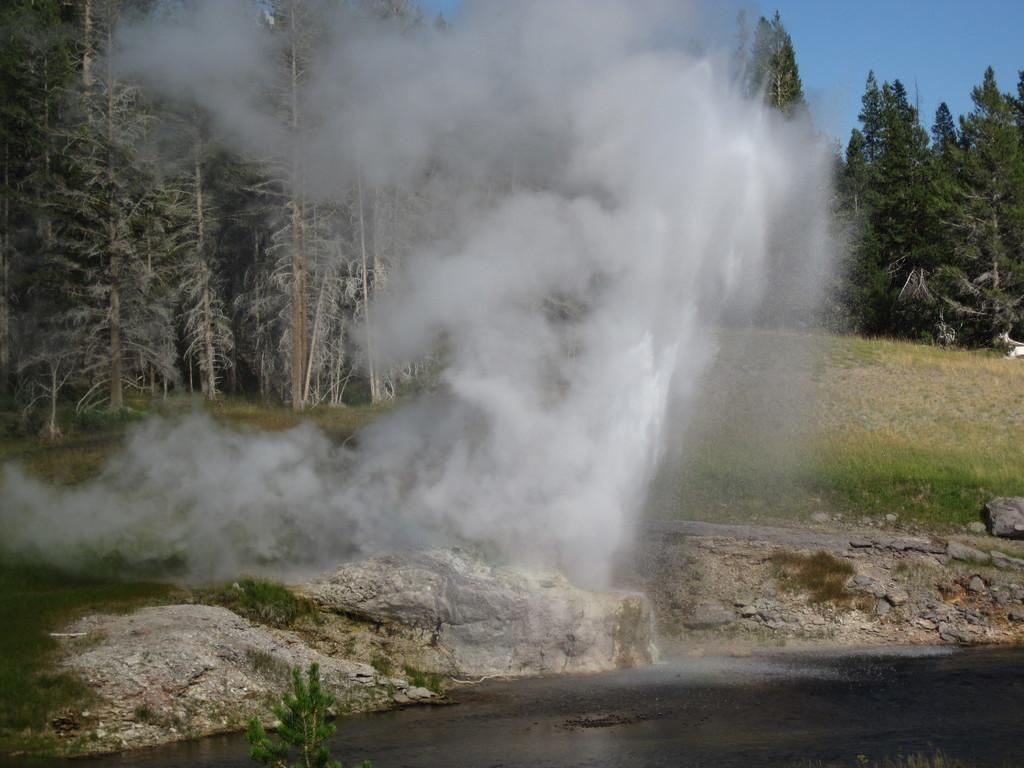What can be seen in the image that is not a solid object? There is smoke in the image. What is located at the bottom of the image? There is a pond at the bottom of the image. What type of natural environment is visible in the background of the image? There are trees in the background of the image. What else can be seen in the background of the image? The sky is visible in the background of the image. What type of feast is being held near the pond in the image? There is no feast or gathering of people present in the image; it only features smoke, a pond, trees, and the sky. How much money is visible in the image? There is no money present in the image. 